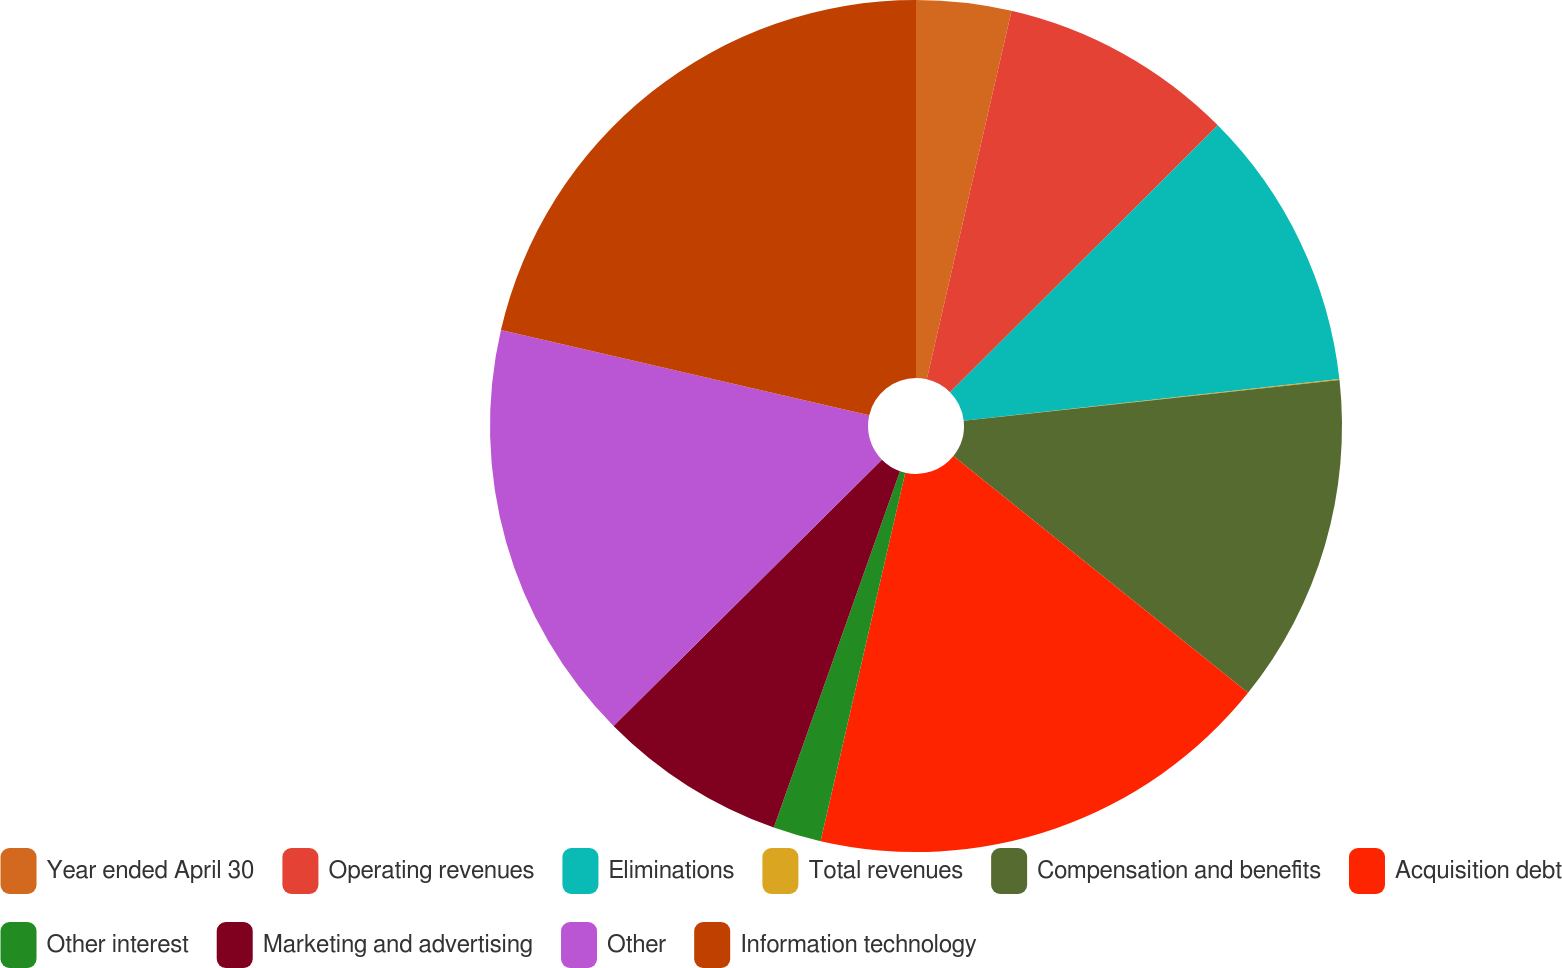Convert chart to OTSL. <chart><loc_0><loc_0><loc_500><loc_500><pie_chart><fcel>Year ended April 30<fcel>Operating revenues<fcel>Eliminations<fcel>Total revenues<fcel>Compensation and benefits<fcel>Acquisition debt<fcel>Other interest<fcel>Marketing and advertising<fcel>Other<fcel>Information technology<nl><fcel>3.6%<fcel>8.93%<fcel>10.71%<fcel>0.04%<fcel>12.49%<fcel>17.82%<fcel>1.82%<fcel>7.15%<fcel>16.05%<fcel>21.38%<nl></chart> 